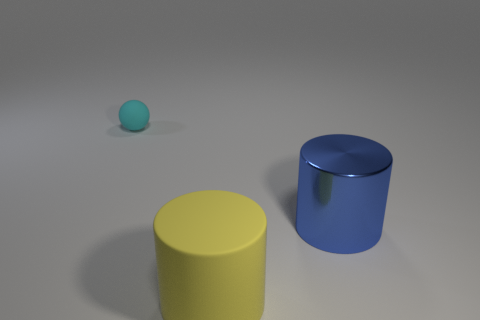Are there any other things that are the same size as the ball?
Keep it short and to the point. No. Is there anything else that has the same material as the blue object?
Ensure brevity in your answer.  No. How many other objects are the same size as the metallic cylinder?
Make the answer very short. 1. Do the blue metal cylinder and the cylinder on the left side of the big blue shiny thing have the same size?
Your answer should be compact. Yes. The other rubber cylinder that is the same size as the blue cylinder is what color?
Your response must be concise. Yellow. The yellow cylinder has what size?
Give a very brief answer. Large. Is the material of the cyan object that is behind the yellow object the same as the big yellow object?
Your answer should be compact. Yes. Do the metal object and the small cyan rubber thing have the same shape?
Provide a succinct answer. No. What shape is the rubber thing to the right of the rubber object that is behind the rubber object that is right of the tiny cyan thing?
Provide a succinct answer. Cylinder. There is a large yellow object that is left of the big shiny cylinder; is its shape the same as the object behind the blue thing?
Provide a succinct answer. No. 